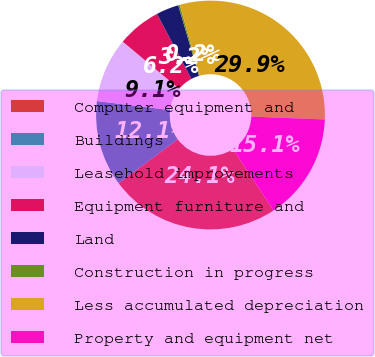Convert chart to OTSL. <chart><loc_0><loc_0><loc_500><loc_500><pie_chart><fcel>Computer equipment and<fcel>Buildings<fcel>Leasehold improvements<fcel>Equipment furniture and<fcel>Land<fcel>Construction in progress<fcel>Less accumulated depreciation<fcel>Property and equipment net<nl><fcel>24.13%<fcel>12.11%<fcel>9.14%<fcel>6.17%<fcel>3.2%<fcel>0.23%<fcel>29.94%<fcel>15.08%<nl></chart> 